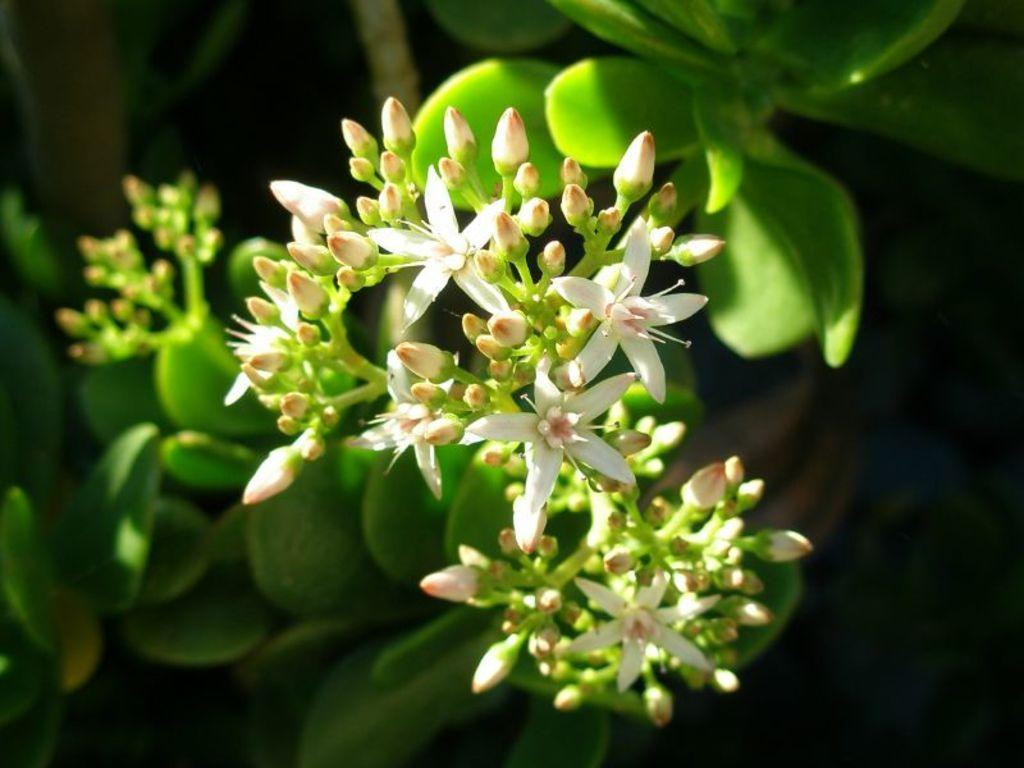Could you give a brief overview of what you see in this image? In this image I can see a tree which is green in color and to the tree I can see few flowers which are white and pink in color. I can see the black colored background. 